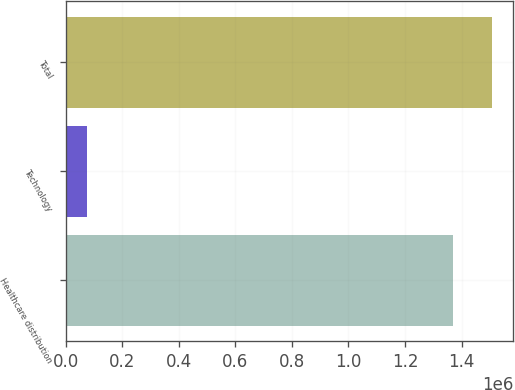Convert chart. <chart><loc_0><loc_0><loc_500><loc_500><bar_chart><fcel>Healthcare distribution<fcel>Technology<fcel>Total<nl><fcel>1.36924e+06<fcel>75030<fcel>1.50617e+06<nl></chart> 